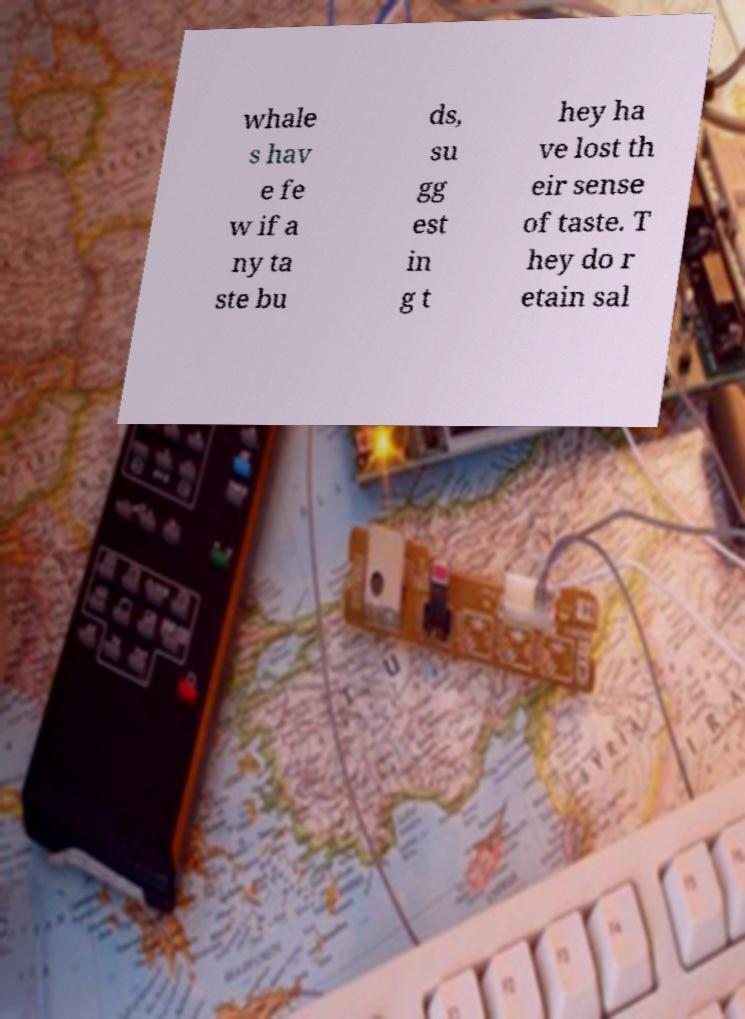Could you extract and type out the text from this image? whale s hav e fe w if a ny ta ste bu ds, su gg est in g t hey ha ve lost th eir sense of taste. T hey do r etain sal 